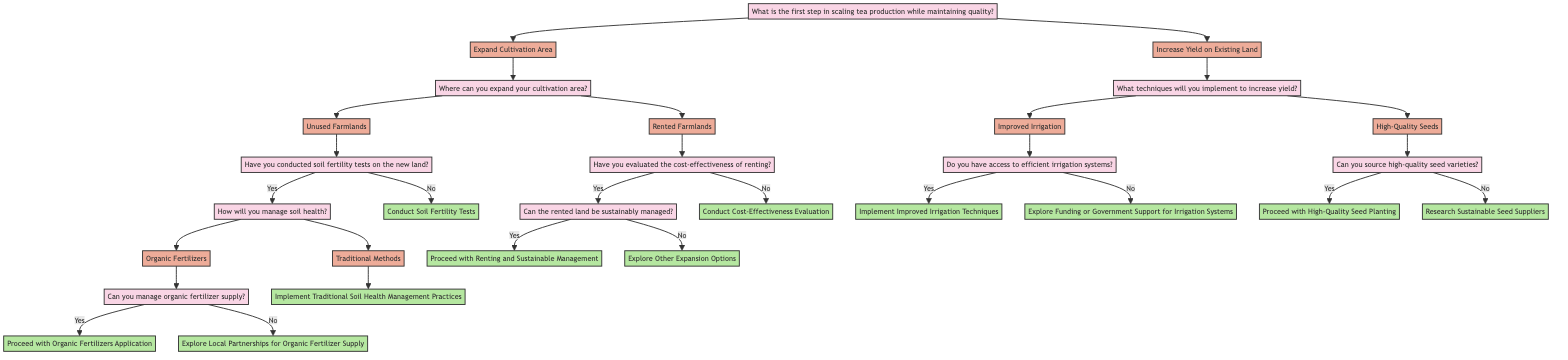What is the first step in scaling tea production while maintaining quality? The diagram begins with the question, "What is the first step in scaling tea production while maintaining quality?" This question leads to two options, "Expand Cultivation Area" and "Increase Yield on Existing Land."
Answer: Expand Cultivation Area or Increase Yield on Existing Land How many options are available for expanding the cultivation area? The node for "Where can you expand your cultivation area?" branches out into two options: "Unused Farmlands" and "Rented Farmlands." Therefore, there are two options available.
Answer: Two What should you do if you haven't conducted soil fertility tests on the new land? According to the diagram, if soil fertility tests have not been conducted on the new land, the action to take is "Conduct Soil Fertility Tests." This is the direct outcome for that condition.
Answer: Conduct Soil Fertility Tests If you have access to efficient irrigation systems, what is your next step? The flowchart indicates that if you have access to efficient irrigation systems, the next step is to "Implement Improved Irrigation Techniques." This is a direct decision following that condition.
Answer: Implement Improved Irrigation Techniques What happens if you cannot manage organic fertilizer supply? The diagram states that if you cannot manage organic fertilizer supply, you should "Explore Local Partnerships for Organic Fertilizer Supply." This is the action to take in that specific scenario.
Answer: Explore Local Partnerships for Organic Fertilizer Supply What must you evaluate before renting farmlands? Before renting farmlands, the diagram indicates that you must first evaluate "the cost-effectiveness of renting." This is a prerequisite step detailing what needs to be analyzed.
Answer: Conduct Cost-Effectiveness Evaluation Can you proceed with high-quality seed planting if you can source high-quality seed varieties? According to the diagram, yes, you can proceed with "High-Quality Seed Planting" if you can source high-quality seed varieties. This response is dependent on the earlier question regarding sourcing.
Answer: Proceed with High-Quality Seed Planting What should be done if the rented land cannot be sustainably managed? The decision tree states that if the rented land cannot be sustainably managed, the next step is to "Explore Other Expansion Options." This indicates a shift in the strategy based on the evaluation of the rented land.
Answer: Explore Other Expansion Options 